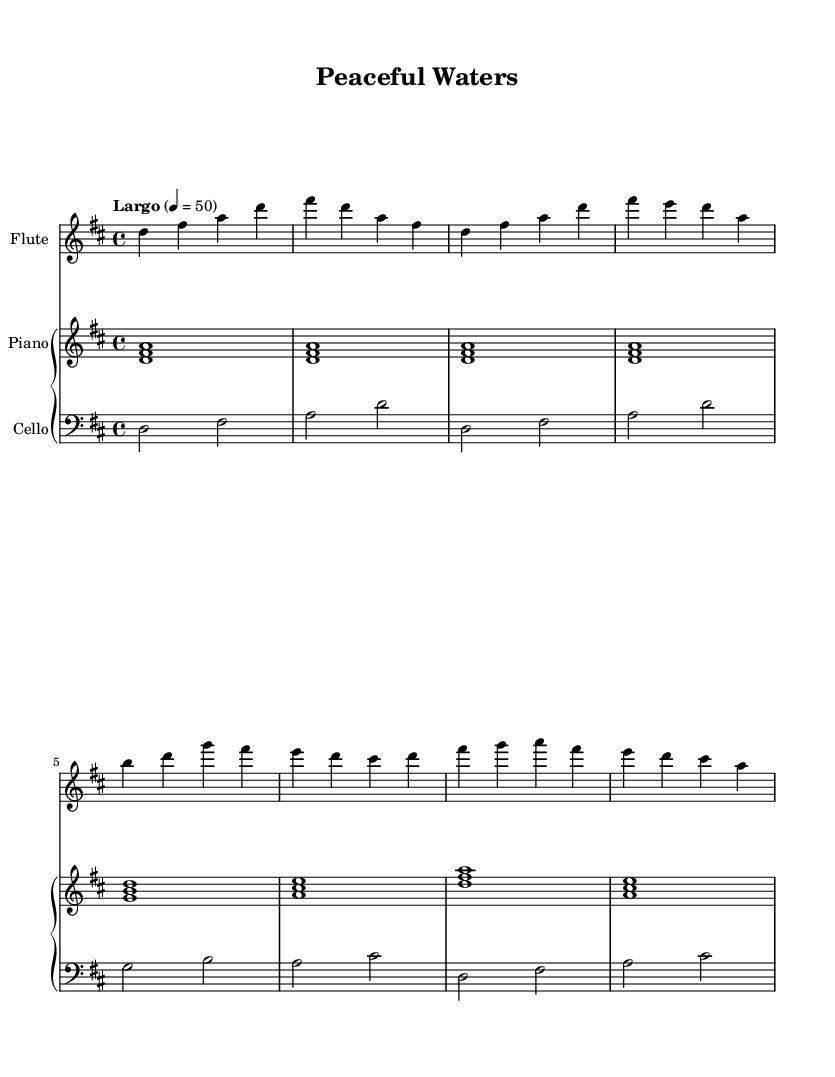What is the key signature of this music? The key signature is D major, which has two sharps (F# and C#).
Answer: D major What is the time signature of this music? The time signature is 4/4, meaning there are four beats per measure.
Answer: 4/4 What is the tempo marking of this piece? The tempo marking is "Largo," indicating a slow and broad tempo.
Answer: Largo What instruments are included in this score? The score includes Flute, Piano, and Cello.
Answer: Flute, Piano, Cello How many measures are in section A? Section A consists of 4 measures as counted from the sheet music provided.
Answer: 4 What is the first note of the piece? The first note of the piece is D.
Answer: D What is the overall mood conveyed by the tempo and dynamics in this music? The mood is calm and peaceful, suggested by the slow tempo and smooth melodic lines.
Answer: Calm 